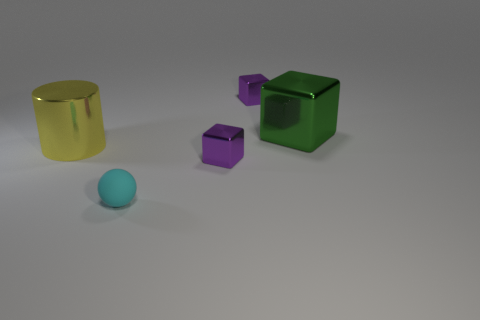Subtract all tiny purple cubes. How many cubes are left? 1 Subtract all brown blocks. Subtract all red spheres. How many blocks are left? 3 Add 3 yellow metal objects. How many objects exist? 8 Subtract all green blocks. How many blocks are left? 2 Subtract 0 brown cylinders. How many objects are left? 5 Subtract all cylinders. How many objects are left? 4 Subtract 1 cylinders. How many cylinders are left? 0 Subtract all purple spheres. How many yellow cubes are left? 0 Subtract all yellow objects. Subtract all balls. How many objects are left? 3 Add 1 large cylinders. How many large cylinders are left? 2 